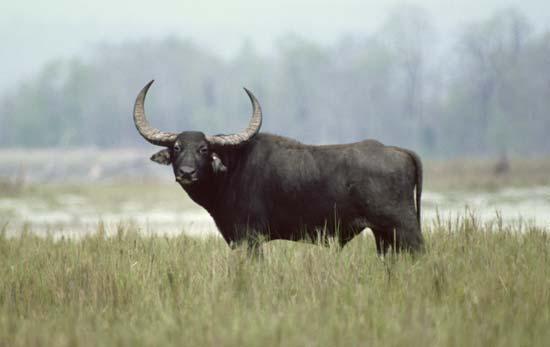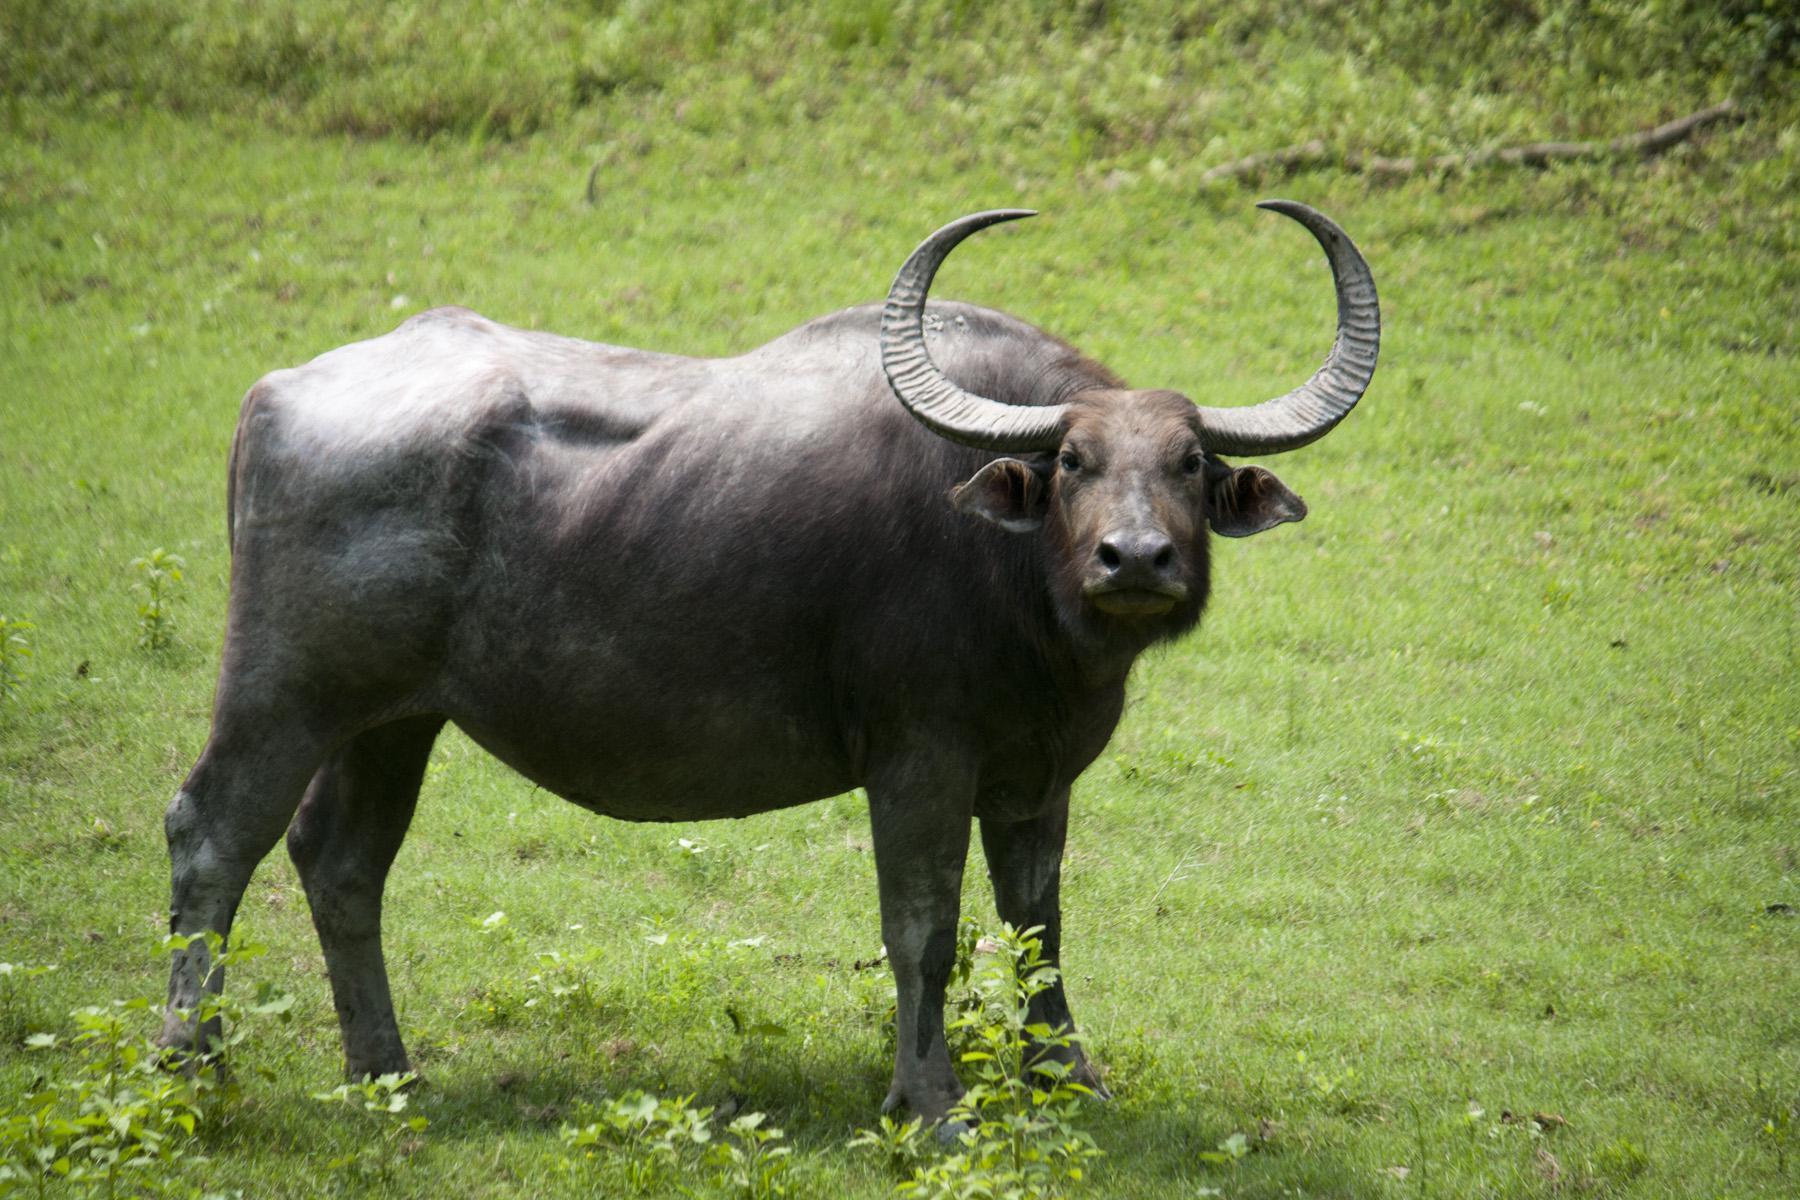The first image is the image on the left, the second image is the image on the right. Assess this claim about the two images: "Right image contains at least twice as many horned animals as the left image.". Correct or not? Answer yes or no. No. 